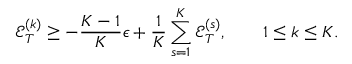Convert formula to latex. <formula><loc_0><loc_0><loc_500><loc_500>{ \mathcal { E } } _ { T } ^ { ( k ) } \geq - \frac { K - 1 } K \epsilon + \frac { 1 } { K } \sum _ { s = 1 } ^ { K } { \mathcal { E } } _ { T } ^ { ( s ) } , \quad 1 \leq k \leq K .</formula> 